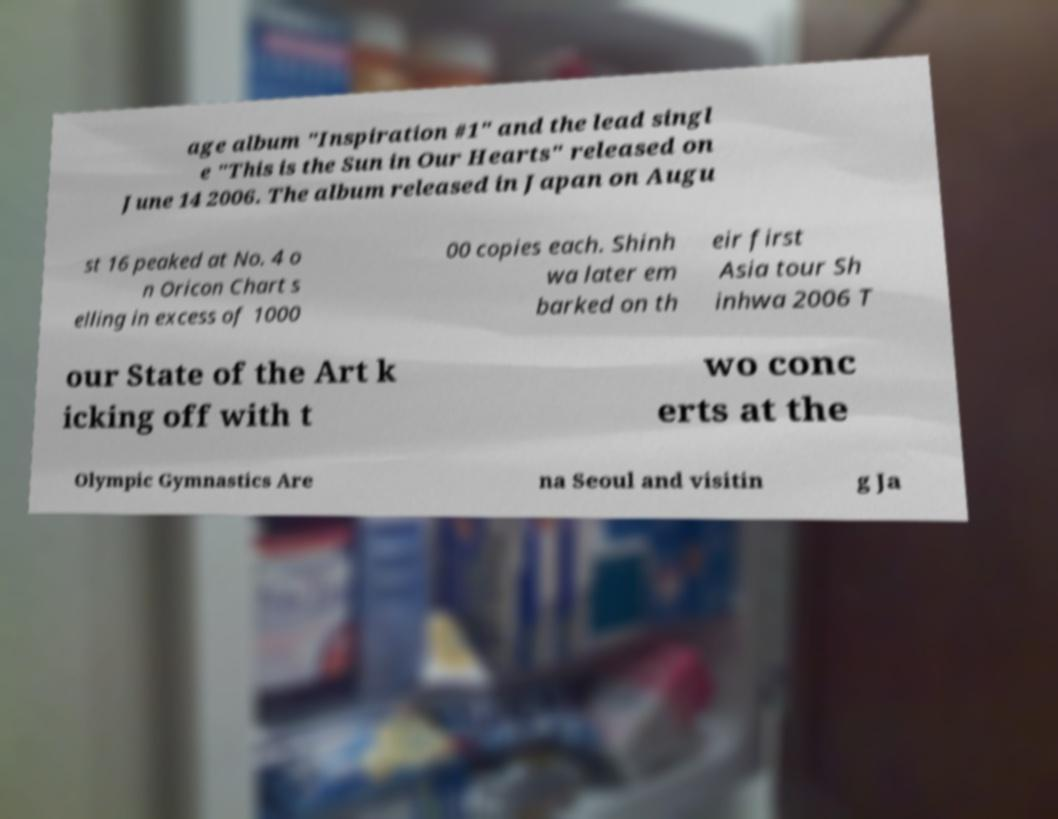I need the written content from this picture converted into text. Can you do that? age album "Inspiration #1" and the lead singl e "This is the Sun in Our Hearts" released on June 14 2006. The album released in Japan on Augu st 16 peaked at No. 4 o n Oricon Chart s elling in excess of 1000 00 copies each. Shinh wa later em barked on th eir first Asia tour Sh inhwa 2006 T our State of the Art k icking off with t wo conc erts at the Olympic Gymnastics Are na Seoul and visitin g Ja 